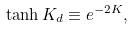<formula> <loc_0><loc_0><loc_500><loc_500>\tanh K _ { d } \equiv e ^ { - 2 K } ,</formula> 